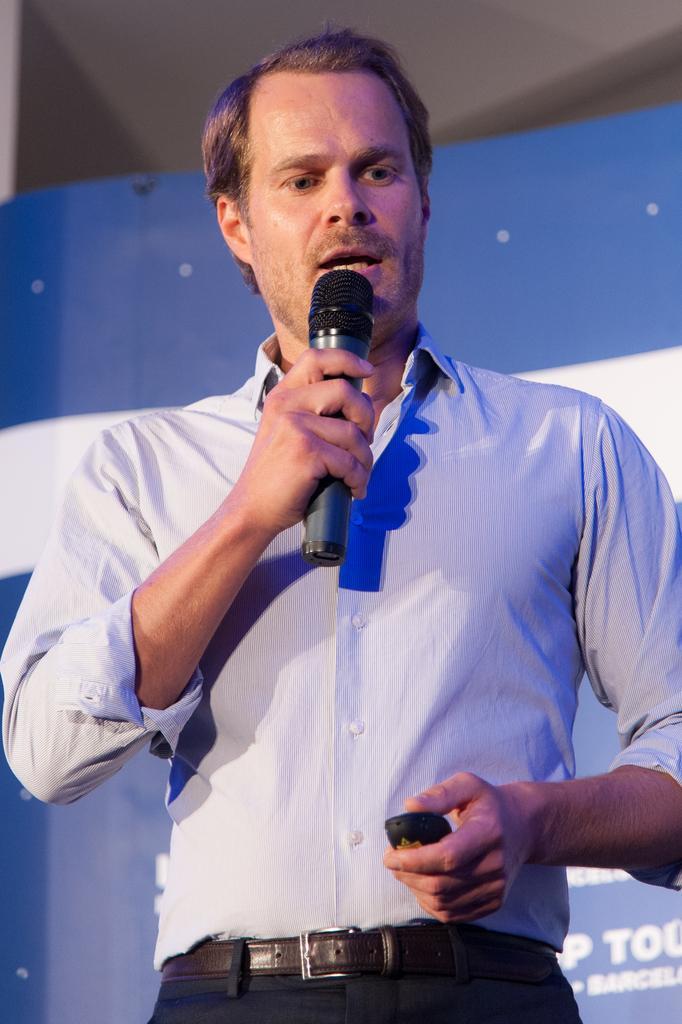In one or two sentences, can you explain what this image depicts? This is a picture of a man, the man holding the microphone and the man is talking and the background of the man is a banner with blue and white color. 